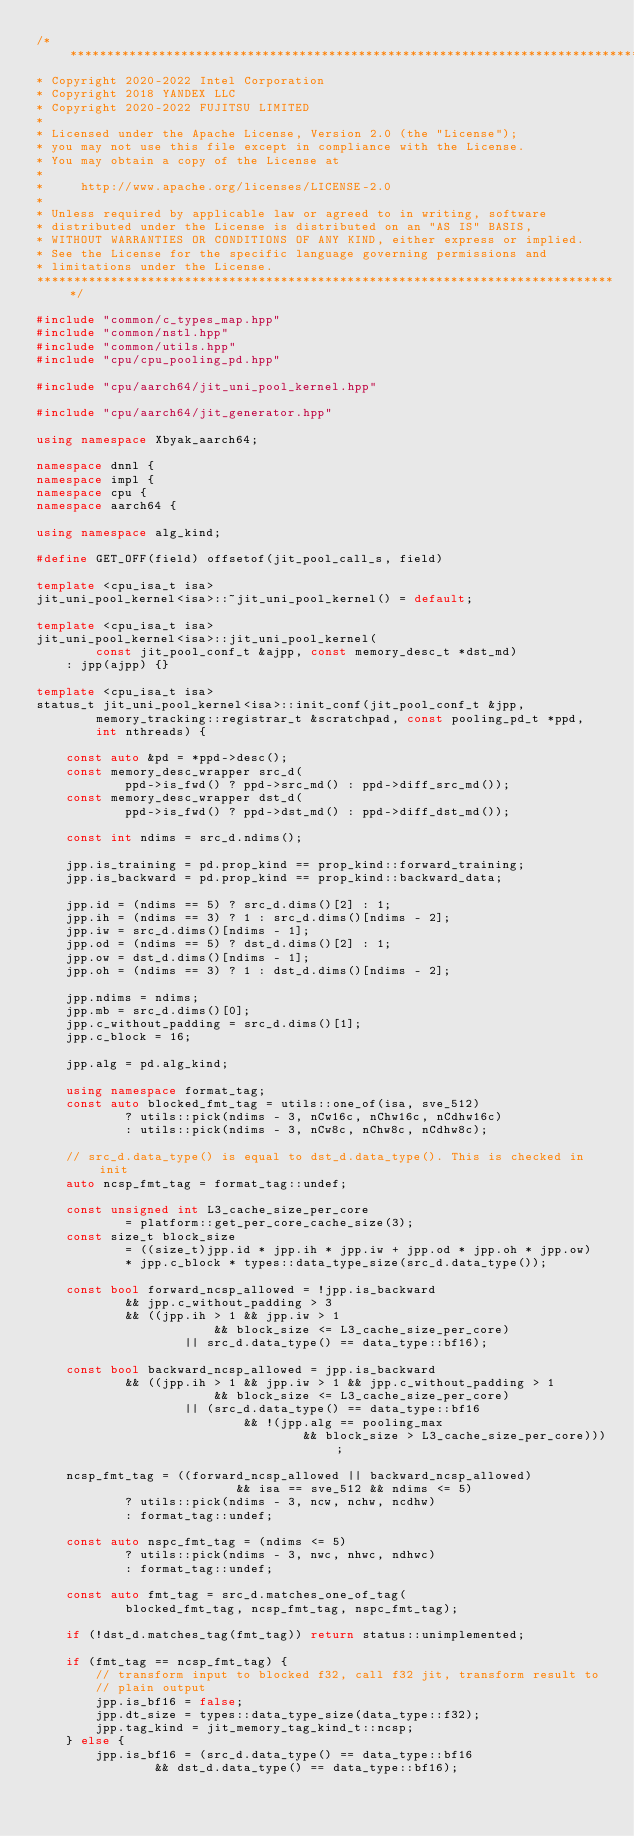Convert code to text. <code><loc_0><loc_0><loc_500><loc_500><_C++_>/*******************************************************************************
* Copyright 2020-2022 Intel Corporation
* Copyright 2018 YANDEX LLC
* Copyright 2020-2022 FUJITSU LIMITED
*
* Licensed under the Apache License, Version 2.0 (the "License");
* you may not use this file except in compliance with the License.
* You may obtain a copy of the License at
*
*     http://www.apache.org/licenses/LICENSE-2.0
*
* Unless required by applicable law or agreed to in writing, software
* distributed under the License is distributed on an "AS IS" BASIS,
* WITHOUT WARRANTIES OR CONDITIONS OF ANY KIND, either express or implied.
* See the License for the specific language governing permissions and
* limitations under the License.
*******************************************************************************/

#include "common/c_types_map.hpp"
#include "common/nstl.hpp"
#include "common/utils.hpp"
#include "cpu/cpu_pooling_pd.hpp"

#include "cpu/aarch64/jit_uni_pool_kernel.hpp"

#include "cpu/aarch64/jit_generator.hpp"

using namespace Xbyak_aarch64;

namespace dnnl {
namespace impl {
namespace cpu {
namespace aarch64 {

using namespace alg_kind;

#define GET_OFF(field) offsetof(jit_pool_call_s, field)

template <cpu_isa_t isa>
jit_uni_pool_kernel<isa>::~jit_uni_pool_kernel() = default;

template <cpu_isa_t isa>
jit_uni_pool_kernel<isa>::jit_uni_pool_kernel(
        const jit_pool_conf_t &ajpp, const memory_desc_t *dst_md)
    : jpp(ajpp) {}

template <cpu_isa_t isa>
status_t jit_uni_pool_kernel<isa>::init_conf(jit_pool_conf_t &jpp,
        memory_tracking::registrar_t &scratchpad, const pooling_pd_t *ppd,
        int nthreads) {

    const auto &pd = *ppd->desc();
    const memory_desc_wrapper src_d(
            ppd->is_fwd() ? ppd->src_md() : ppd->diff_src_md());
    const memory_desc_wrapper dst_d(
            ppd->is_fwd() ? ppd->dst_md() : ppd->diff_dst_md());

    const int ndims = src_d.ndims();

    jpp.is_training = pd.prop_kind == prop_kind::forward_training;
    jpp.is_backward = pd.prop_kind == prop_kind::backward_data;

    jpp.id = (ndims == 5) ? src_d.dims()[2] : 1;
    jpp.ih = (ndims == 3) ? 1 : src_d.dims()[ndims - 2];
    jpp.iw = src_d.dims()[ndims - 1];
    jpp.od = (ndims == 5) ? dst_d.dims()[2] : 1;
    jpp.ow = dst_d.dims()[ndims - 1];
    jpp.oh = (ndims == 3) ? 1 : dst_d.dims()[ndims - 2];

    jpp.ndims = ndims;
    jpp.mb = src_d.dims()[0];
    jpp.c_without_padding = src_d.dims()[1];
    jpp.c_block = 16;

    jpp.alg = pd.alg_kind;

    using namespace format_tag;
    const auto blocked_fmt_tag = utils::one_of(isa, sve_512)
            ? utils::pick(ndims - 3, nCw16c, nChw16c, nCdhw16c)
            : utils::pick(ndims - 3, nCw8c, nChw8c, nCdhw8c);

    // src_d.data_type() is equal to dst_d.data_type(). This is checked in init
    auto ncsp_fmt_tag = format_tag::undef;

    const unsigned int L3_cache_size_per_core
            = platform::get_per_core_cache_size(3);
    const size_t block_size
            = ((size_t)jpp.id * jpp.ih * jpp.iw + jpp.od * jpp.oh * jpp.ow)
            * jpp.c_block * types::data_type_size(src_d.data_type());

    const bool forward_ncsp_allowed = !jpp.is_backward
            && jpp.c_without_padding > 3
            && ((jpp.ih > 1 && jpp.iw > 1
                        && block_size <= L3_cache_size_per_core)
                    || src_d.data_type() == data_type::bf16);

    const bool backward_ncsp_allowed = jpp.is_backward
            && ((jpp.ih > 1 && jpp.iw > 1 && jpp.c_without_padding > 1
                        && block_size <= L3_cache_size_per_core)
                    || (src_d.data_type() == data_type::bf16
                            && !(jpp.alg == pooling_max
                                    && block_size > L3_cache_size_per_core)));

    ncsp_fmt_tag = ((forward_ncsp_allowed || backward_ncsp_allowed)
                           && isa == sve_512 && ndims <= 5)
            ? utils::pick(ndims - 3, ncw, nchw, ncdhw)
            : format_tag::undef;

    const auto nspc_fmt_tag = (ndims <= 5)
            ? utils::pick(ndims - 3, nwc, nhwc, ndhwc)
            : format_tag::undef;

    const auto fmt_tag = src_d.matches_one_of_tag(
            blocked_fmt_tag, ncsp_fmt_tag, nspc_fmt_tag);

    if (!dst_d.matches_tag(fmt_tag)) return status::unimplemented;

    if (fmt_tag == ncsp_fmt_tag) {
        // transform input to blocked f32, call f32 jit, transform result to
        // plain output
        jpp.is_bf16 = false;
        jpp.dt_size = types::data_type_size(data_type::f32);
        jpp.tag_kind = jit_memory_tag_kind_t::ncsp;
    } else {
        jpp.is_bf16 = (src_d.data_type() == data_type::bf16
                && dst_d.data_type() == data_type::bf16);</code> 